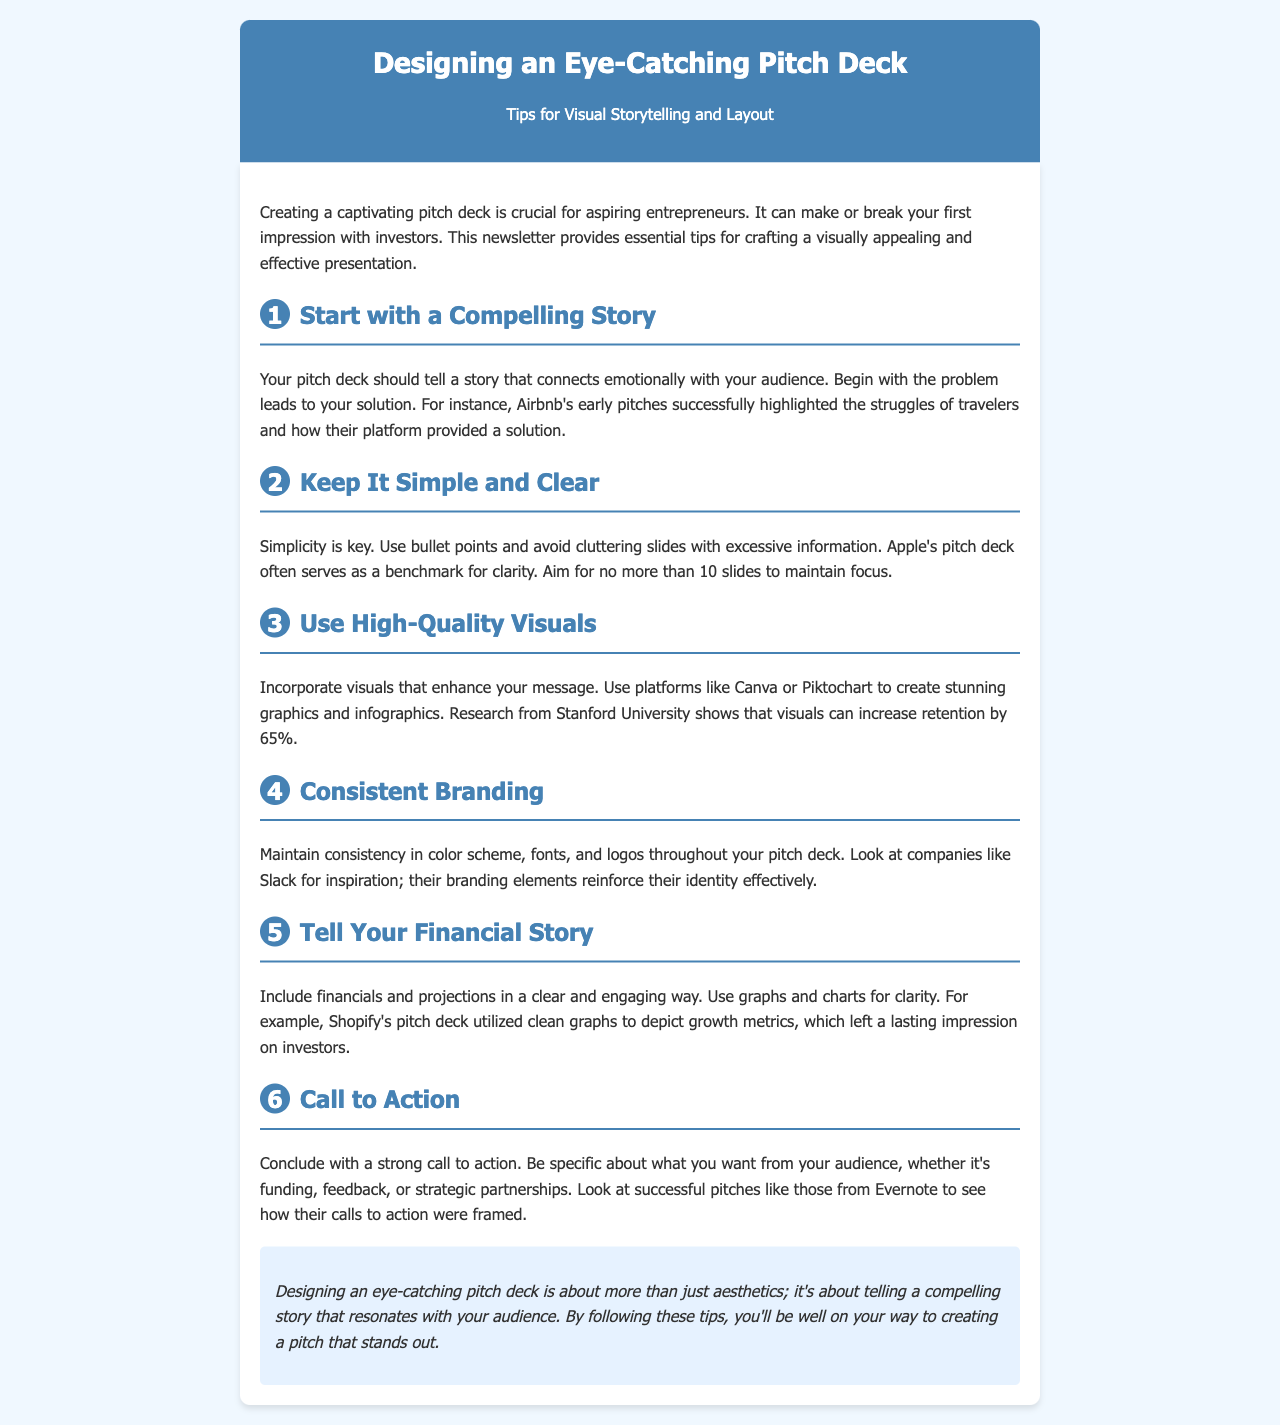What is the main focus of the newsletter? The newsletter discusses tips for creating an engaging pitch deck focused on visual storytelling and layout.
Answer: tips for visual storytelling and layout How many tips are provided in the document? The document lists a total of six tips to help in designing an eye-catching pitch deck.
Answer: six Which company is mentioned as a benchmark for clarity in pitch decks? The document refers to Apple as a benchmark for maintaining simplicity and clarity in pitch decks.
Answer: Apple What did research from Stanford University indicate about visuals? The document states that visuals can increase retention by a certain percentage based on research findings.
Answer: 65% What is the suggested number of slides to maintain focus? According to the document, it is recommended to maintain no more than ten slides in the pitch deck for focus.
Answer: 10 Which company is cited for maintaining effective branding elements? The document mentions Slack as an example of a company with consistent branding elements throughout their pitch deck.
Answer: Slack What is the final section in the newsletter focused on? The conclusion emphasizes the importance of telling a compelling story that resonates with the audience in the pitch deck.
Answer: strong call to action 